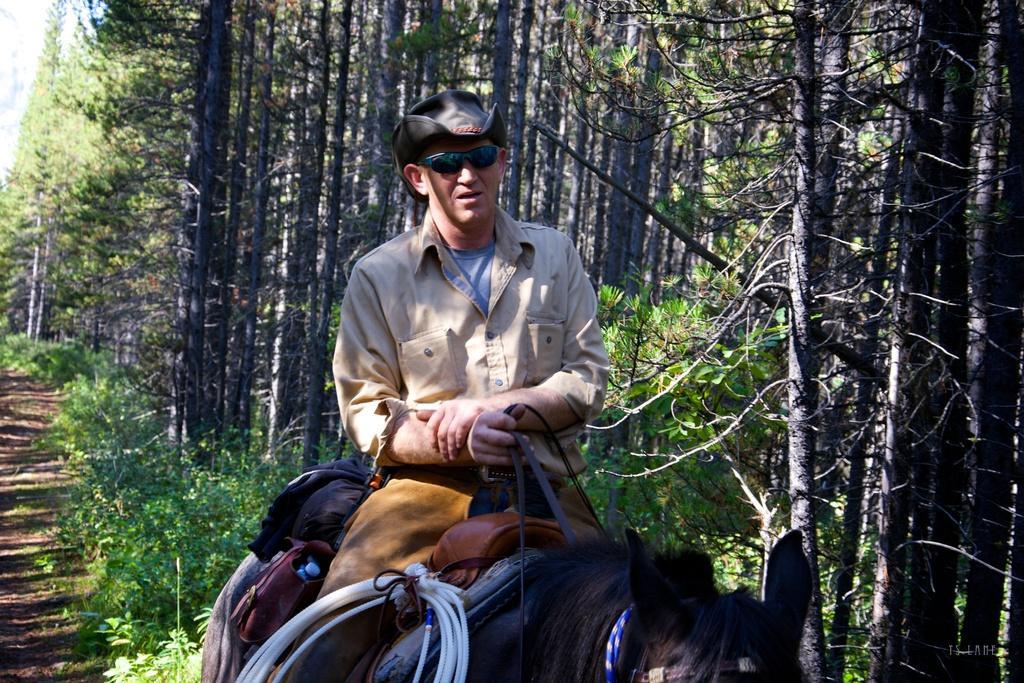Describe this image in one or two sentences. In this picture we can see man wore goggle, cap holding bags, pipes on animal and in background we can see trees, path. 